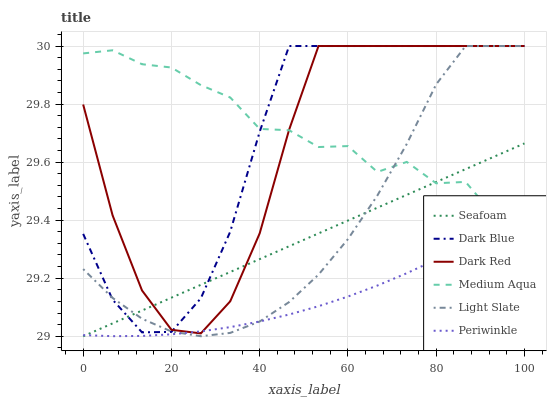Does Periwinkle have the minimum area under the curve?
Answer yes or no. Yes. Does Medium Aqua have the maximum area under the curve?
Answer yes or no. Yes. Does Dark Red have the minimum area under the curve?
Answer yes or no. No. Does Dark Red have the maximum area under the curve?
Answer yes or no. No. Is Seafoam the smoothest?
Answer yes or no. Yes. Is Dark Red the roughest?
Answer yes or no. Yes. Is Dark Red the smoothest?
Answer yes or no. No. Is Seafoam the roughest?
Answer yes or no. No. Does Seafoam have the lowest value?
Answer yes or no. Yes. Does Dark Red have the lowest value?
Answer yes or no. No. Does Dark Blue have the highest value?
Answer yes or no. Yes. Does Seafoam have the highest value?
Answer yes or no. No. Is Periwinkle less than Dark Blue?
Answer yes or no. Yes. Is Dark Blue greater than Periwinkle?
Answer yes or no. Yes. Does Light Slate intersect Periwinkle?
Answer yes or no. Yes. Is Light Slate less than Periwinkle?
Answer yes or no. No. Is Light Slate greater than Periwinkle?
Answer yes or no. No. Does Periwinkle intersect Dark Blue?
Answer yes or no. No. 